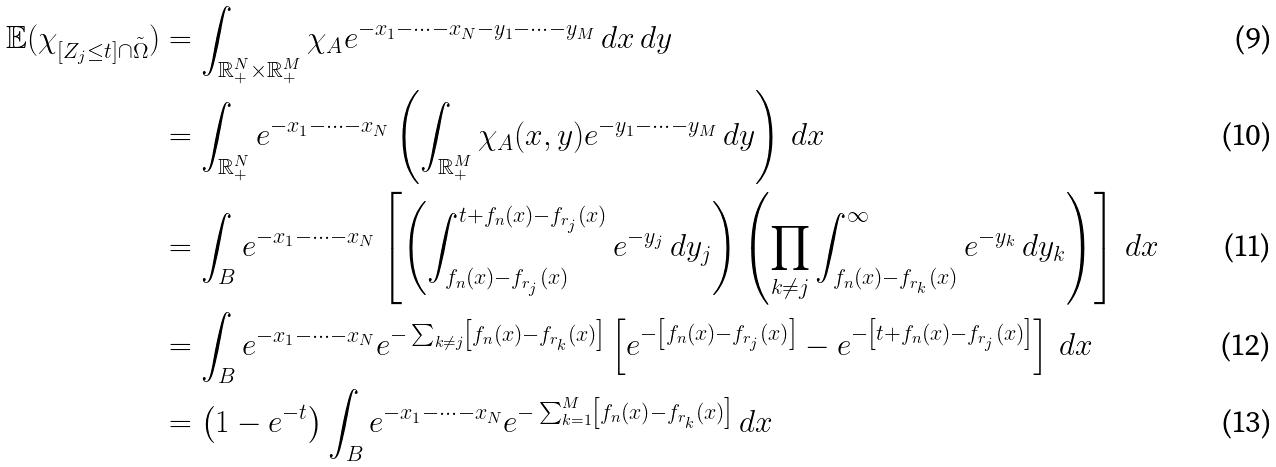Convert formula to latex. <formula><loc_0><loc_0><loc_500><loc_500>\mathbb { E } ( \chi _ { [ Z _ { j } \leq t ] \cap \tilde { \Omega } } ) & = \int _ { \mathbb { R } _ { + } ^ { N } \times \mathbb { R } _ { + } ^ { M } } \chi _ { A } e ^ { - x _ { 1 } - \dots - x _ { N } - y _ { 1 } - \dots - y _ { M } } \, d x \, d y \\ & = \int _ { \mathbb { R } _ { + } ^ { N } } e ^ { - x _ { 1 } - \dots - x _ { N } } \left ( \int _ { \mathbb { R } _ { + } ^ { M } } \chi _ { A } ( x , y ) e ^ { - y _ { 1 } - \dots - y _ { M } } \, d y \right ) \, d x \\ & = \int _ { B } e ^ { - x _ { 1 } - \dots - x _ { N } } \left [ \left ( \int _ { f _ { n } ( x ) - f _ { r _ { j } } ( x ) } ^ { t + f _ { n } ( x ) - f _ { r _ { j } } ( x ) } e ^ { - y _ { j } } \, d y _ { j } \right ) \left ( \prod _ { k \neq j } \int _ { f _ { n } ( x ) - f _ { r _ { k } } ( x ) } ^ { \infty } e ^ { - y _ { k } } \, d y _ { k } \right ) \right ] \, d x \\ & = \int _ { B } e ^ { - x _ { 1 } - \dots - x _ { N } } e ^ { - \sum _ { k \neq j } \left [ f _ { n } ( x ) - f _ { r _ { k } } ( x ) \right ] } \left [ e ^ { - \left [ f _ { n } ( x ) - f _ { r _ { j } } ( x ) \right ] } - e ^ { - \left [ t + f _ { n } ( x ) - f _ { r _ { j } } ( x ) \right ] } \right ] \, d x \\ & = \left ( 1 - e ^ { - t } \right ) \int _ { B } e ^ { - x _ { 1 } - \dots - x _ { N } } e ^ { - \sum _ { k = 1 } ^ { M } \left [ f _ { n } ( x ) - f _ { r _ { k } } ( x ) \right ] } \, d x</formula> 